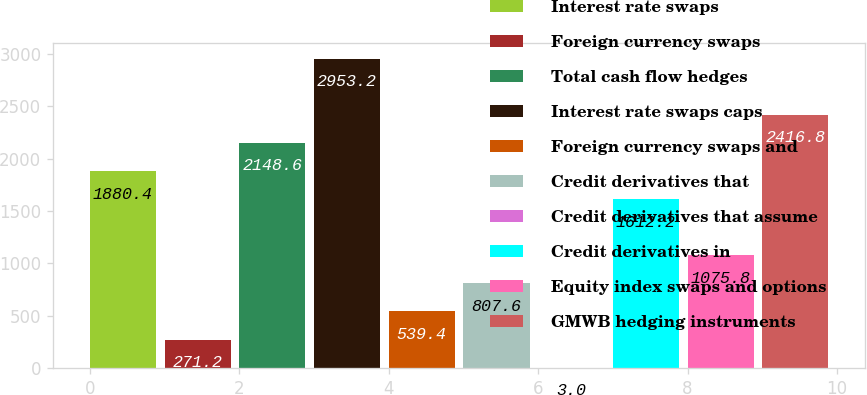<chart> <loc_0><loc_0><loc_500><loc_500><bar_chart><fcel>Interest rate swaps<fcel>Foreign currency swaps<fcel>Total cash flow hedges<fcel>Interest rate swaps caps<fcel>Foreign currency swaps and<fcel>Credit derivatives that<fcel>Credit derivatives that assume<fcel>Credit derivatives in<fcel>Equity index swaps and options<fcel>GMWB hedging instruments<nl><fcel>1880.4<fcel>271.2<fcel>2148.6<fcel>2953.2<fcel>539.4<fcel>807.6<fcel>3<fcel>1612.2<fcel>1075.8<fcel>2416.8<nl></chart> 